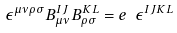Convert formula to latex. <formula><loc_0><loc_0><loc_500><loc_500>\epsilon ^ { \mu \nu \rho \sigma } B ^ { I J } _ { \mu \nu } B ^ { K L } _ { \rho \sigma } = e \ \epsilon ^ { I J K L }</formula> 